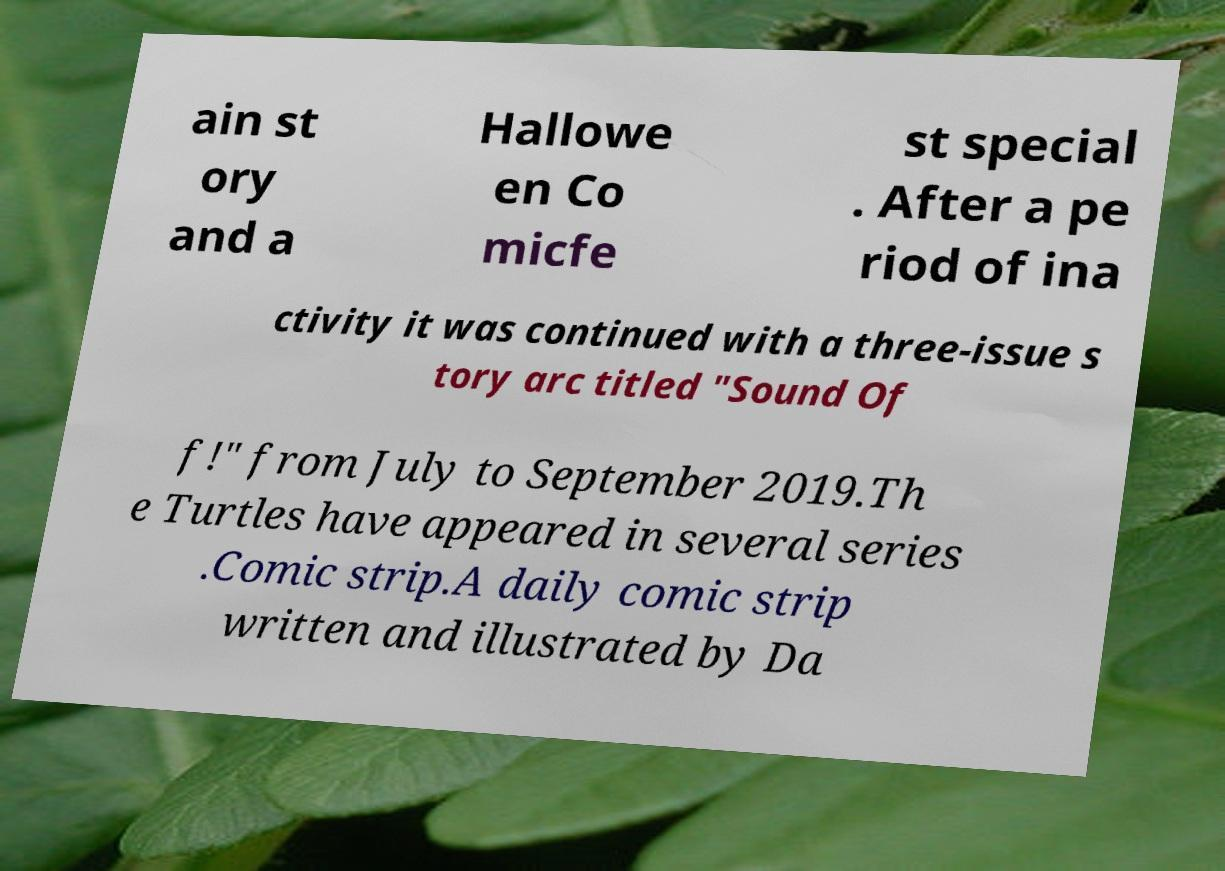Please read and relay the text visible in this image. What does it say? ain st ory and a Hallowe en Co micfe st special . After a pe riod of ina ctivity it was continued with a three-issue s tory arc titled "Sound Of f!" from July to September 2019.Th e Turtles have appeared in several series .Comic strip.A daily comic strip written and illustrated by Da 